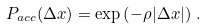Convert formula to latex. <formula><loc_0><loc_0><loc_500><loc_500>P _ { a c c } ( \Delta x ) = \exp \left ( - \rho | \Delta x | \right ) \, .</formula> 